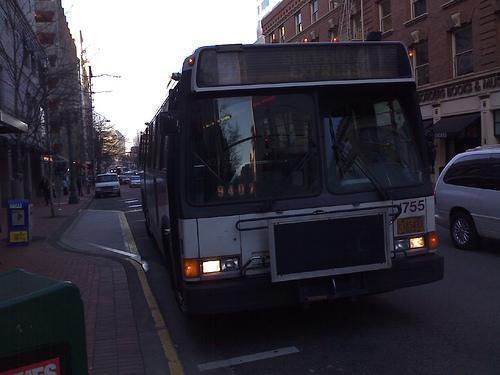What is the bus next to?
Select the correct answer and articulate reasoning with the following format: 'Answer: answer
Rationale: rationale.'
Options: Palm tree, curb, cat, baby. Answer: curb.
Rationale: The side of the road has some stores in front. 